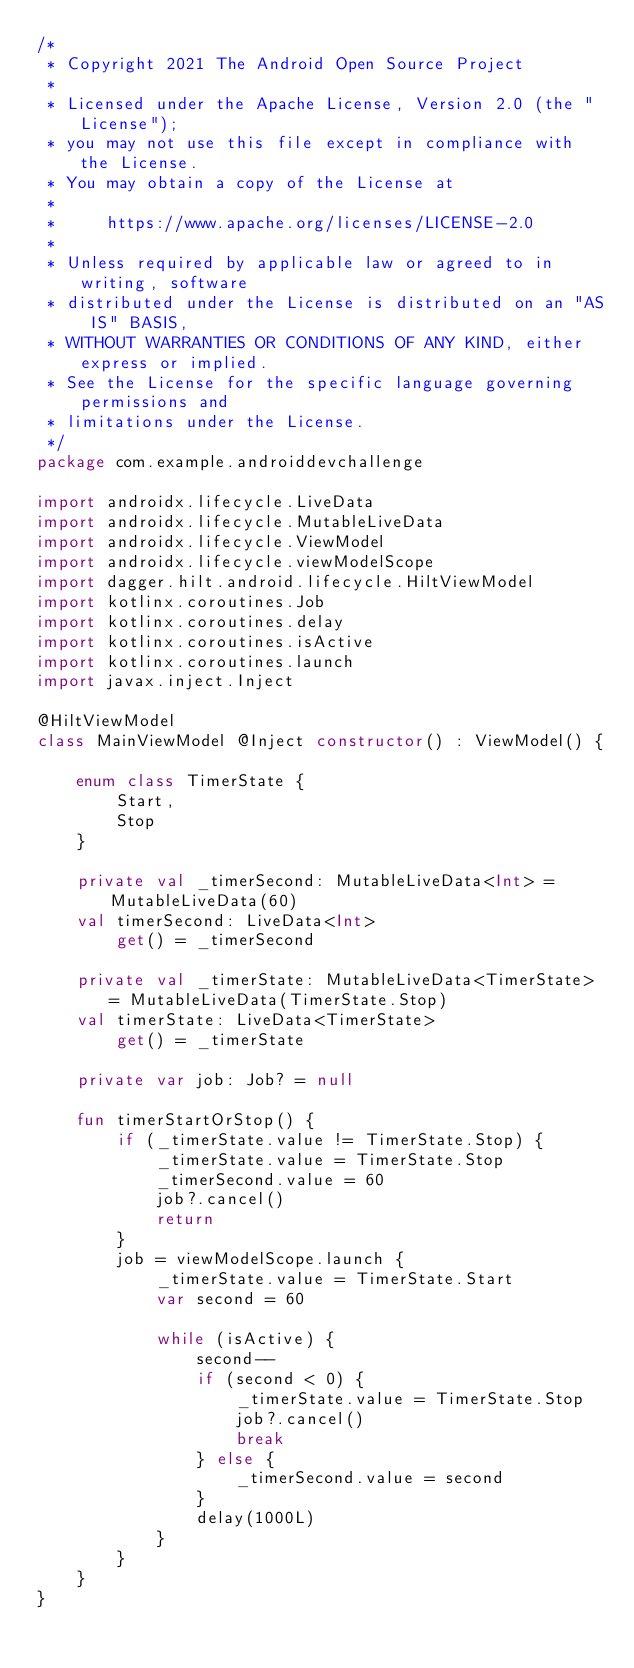<code> <loc_0><loc_0><loc_500><loc_500><_Kotlin_>/*
 * Copyright 2021 The Android Open Source Project
 *
 * Licensed under the Apache License, Version 2.0 (the "License");
 * you may not use this file except in compliance with the License.
 * You may obtain a copy of the License at
 *
 *     https://www.apache.org/licenses/LICENSE-2.0
 *
 * Unless required by applicable law or agreed to in writing, software
 * distributed under the License is distributed on an "AS IS" BASIS,
 * WITHOUT WARRANTIES OR CONDITIONS OF ANY KIND, either express or implied.
 * See the License for the specific language governing permissions and
 * limitations under the License.
 */
package com.example.androiddevchallenge

import androidx.lifecycle.LiveData
import androidx.lifecycle.MutableLiveData
import androidx.lifecycle.ViewModel
import androidx.lifecycle.viewModelScope
import dagger.hilt.android.lifecycle.HiltViewModel
import kotlinx.coroutines.Job
import kotlinx.coroutines.delay
import kotlinx.coroutines.isActive
import kotlinx.coroutines.launch
import javax.inject.Inject

@HiltViewModel
class MainViewModel @Inject constructor() : ViewModel() {

    enum class TimerState {
        Start,
        Stop
    }

    private val _timerSecond: MutableLiveData<Int> = MutableLiveData(60)
    val timerSecond: LiveData<Int>
        get() = _timerSecond

    private val _timerState: MutableLiveData<TimerState> = MutableLiveData(TimerState.Stop)
    val timerState: LiveData<TimerState>
        get() = _timerState

    private var job: Job? = null

    fun timerStartOrStop() {
        if (_timerState.value != TimerState.Stop) {
            _timerState.value = TimerState.Stop
            _timerSecond.value = 60
            job?.cancel()
            return
        }
        job = viewModelScope.launch {
            _timerState.value = TimerState.Start
            var second = 60

            while (isActive) {
                second--
                if (second < 0) {
                    _timerState.value = TimerState.Stop
                    job?.cancel()
                    break
                } else {
                    _timerSecond.value = second
                }
                delay(1000L)
            }
        }
    }
}
</code> 